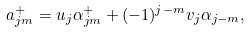<formula> <loc_0><loc_0><loc_500><loc_500>a _ { j m } ^ { + } = u _ { j } \alpha _ { j m } ^ { + } + ( - 1 ) ^ { j - m } v _ { j } \alpha _ { j - m } ,</formula> 